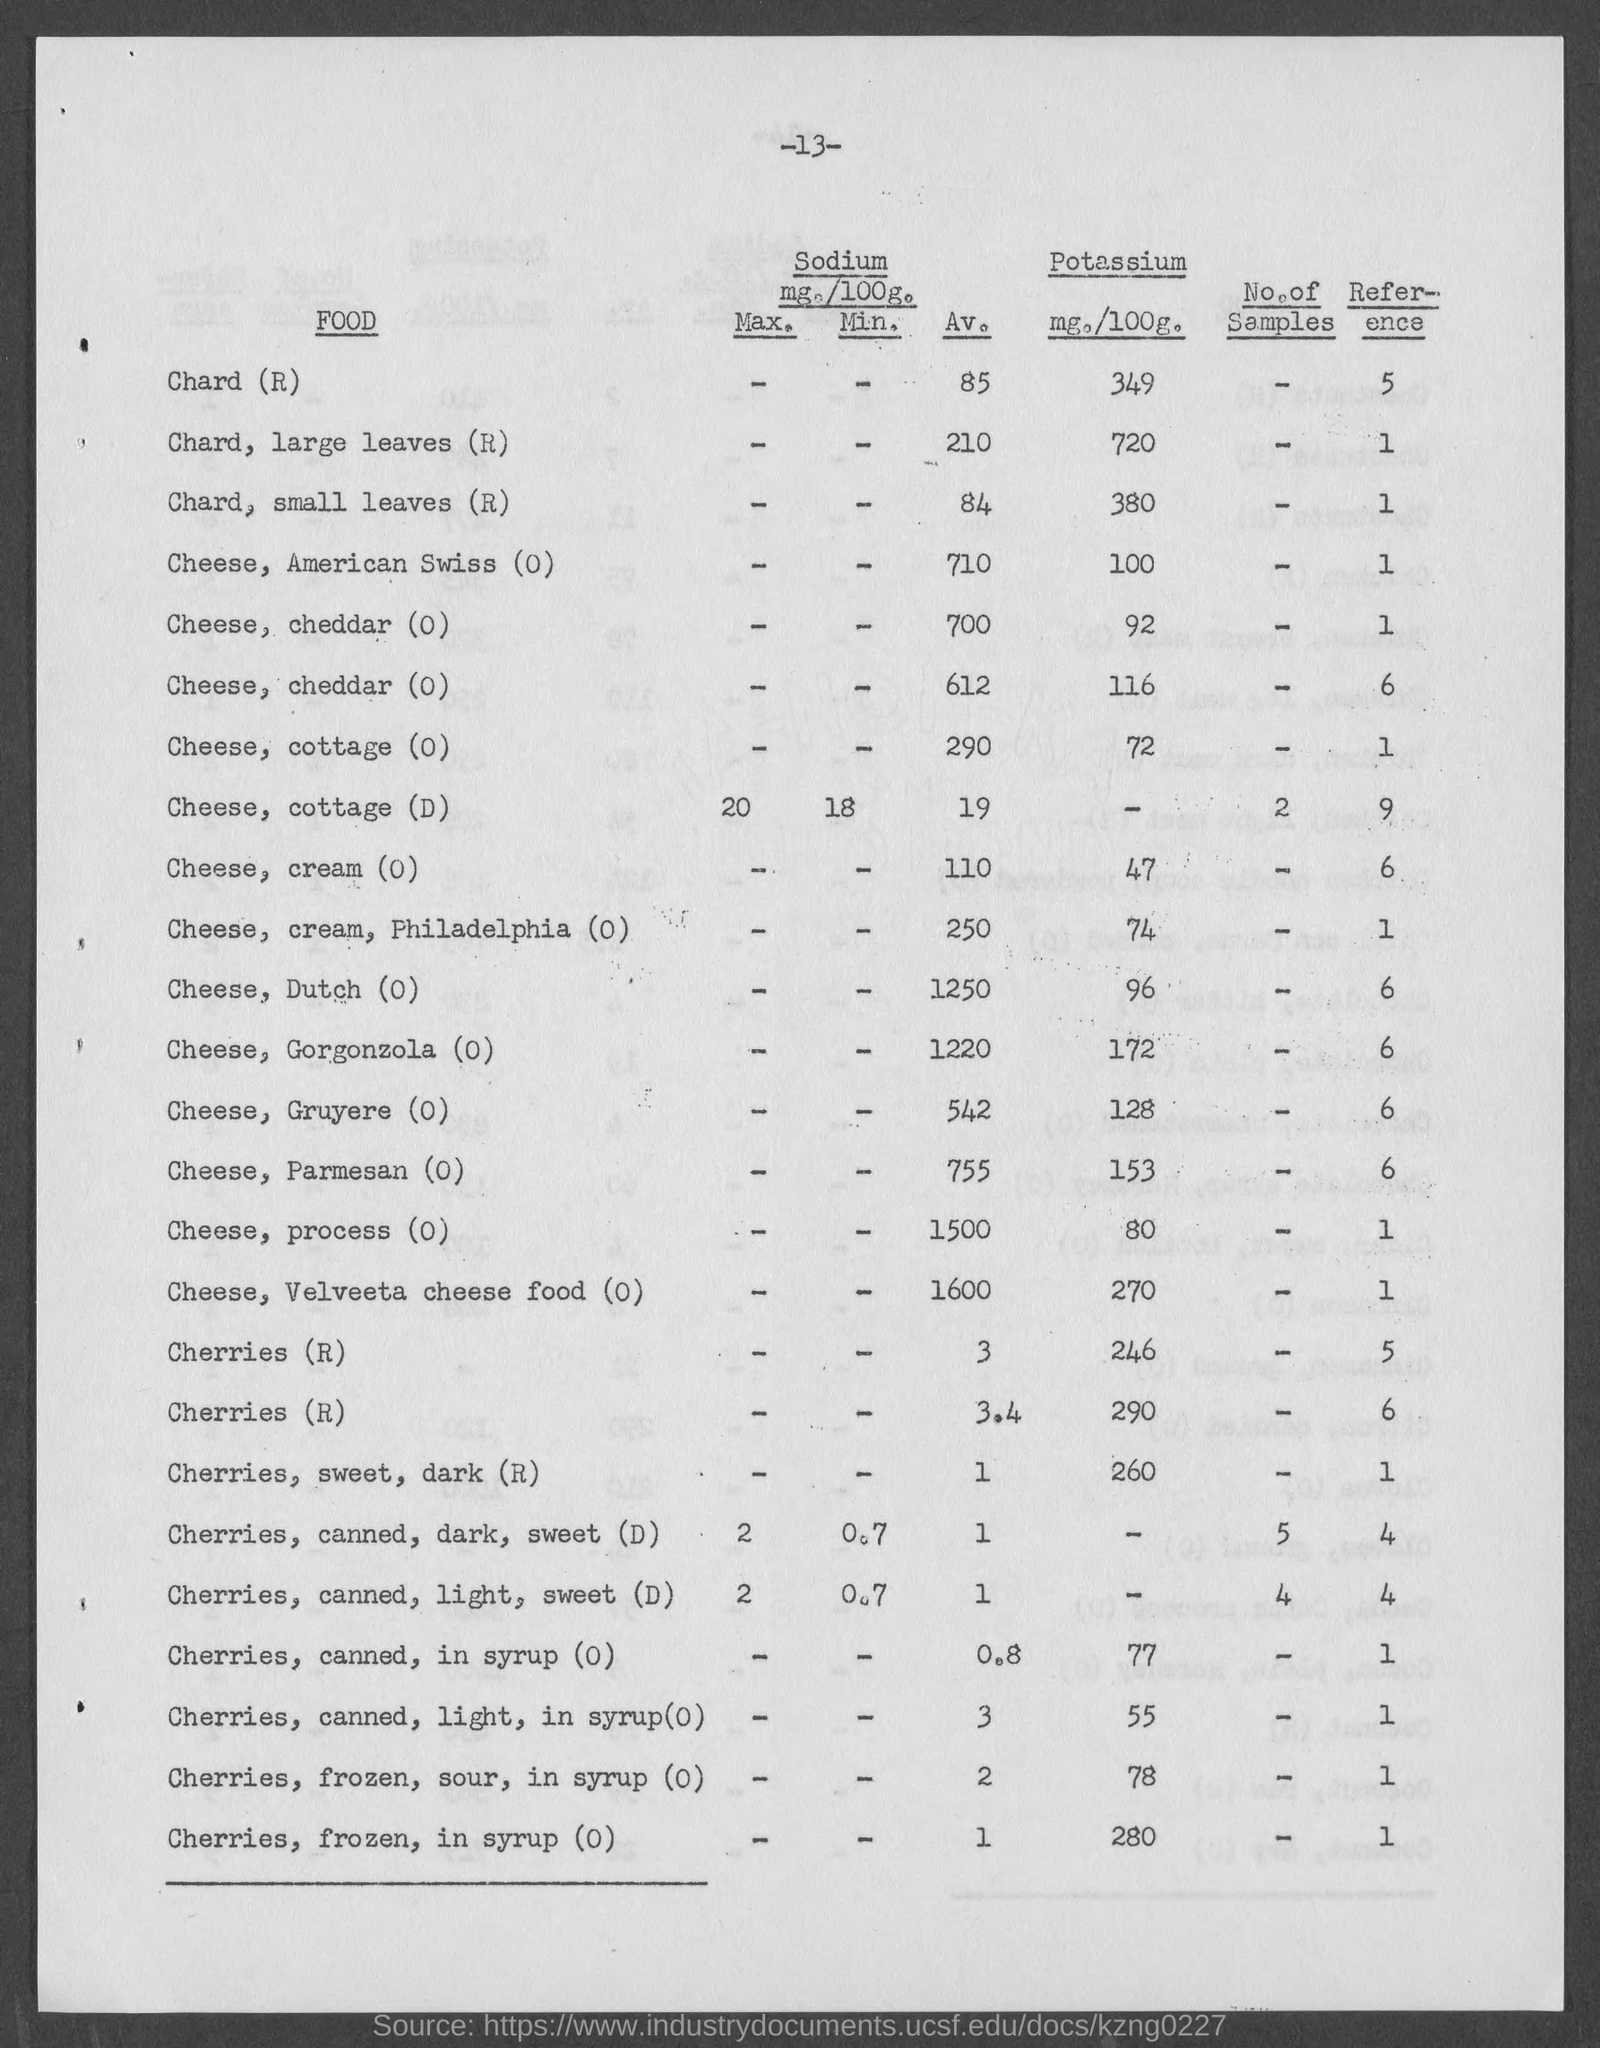Specify some key components in this picture. The average amount of sodium present in cheese, specifically velveeta cheese food, is 1600 milligrams. 